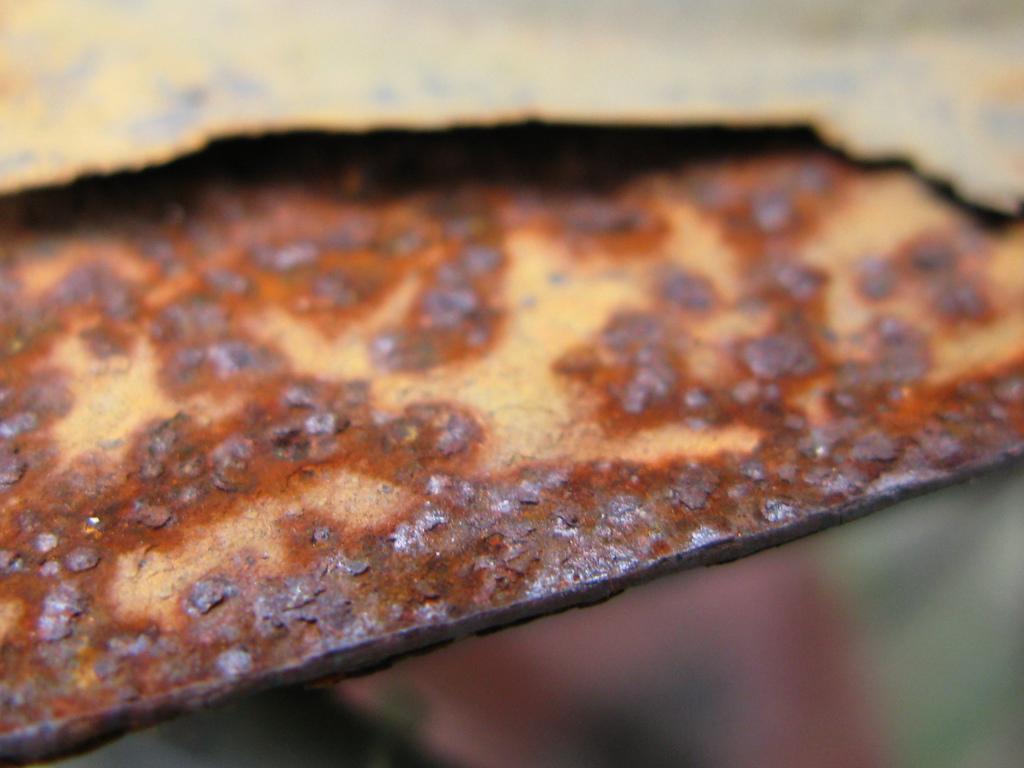Describe this image in one or two sentences. In this image we can see a piece of iron with rust. 